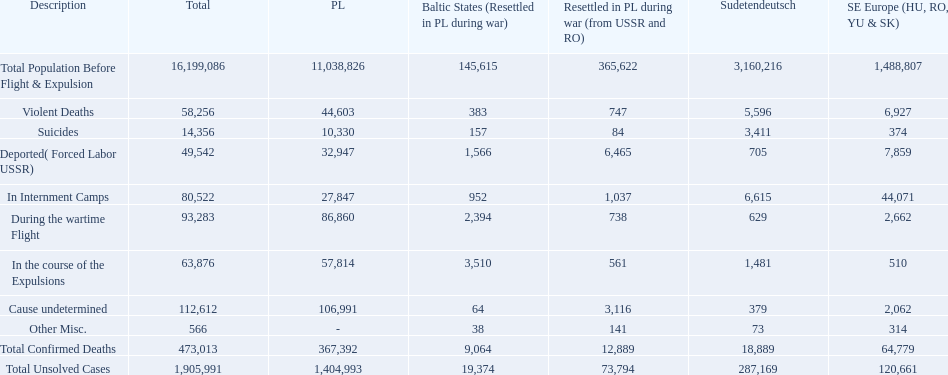What are the numbers of violent deaths across the area? 44,603, 383, 747, 5,596, 6,927. What is the total number of violent deaths of the area? 58,256. Could you parse the entire table? {'header': ['Description', 'Total', 'PL', 'Baltic States (Resettled in PL during war)', 'Resettled in PL during war (from USSR and RO)', 'Sudetendeutsch', 'SE Europe (HU, RO, YU & SK)'], 'rows': [['Total Population Before Flight & Expulsion', '16,199,086', '11,038,826', '145,615', '365,622', '3,160,216', '1,488,807'], ['Violent Deaths', '58,256', '44,603', '383', '747', '5,596', '6,927'], ['Suicides', '14,356', '10,330', '157', '84', '3,411', '374'], ['Deported( Forced Labor USSR)', '49,542', '32,947', '1,566', '6,465', '705', '7,859'], ['In Internment Camps', '80,522', '27,847', '952', '1,037', '6,615', '44,071'], ['During the wartime Flight', '93,283', '86,860', '2,394', '738', '629', '2,662'], ['In the course of the Expulsions', '63,876', '57,814', '3,510', '561', '1,481', '510'], ['Cause undetermined', '112,612', '106,991', '64', '3,116', '379', '2,062'], ['Other Misc.', '566', '-', '38', '141', '73', '314'], ['Total Confirmed Deaths', '473,013', '367,392', '9,064', '12,889', '18,889', '64,779'], ['Total Unsolved Cases', '1,905,991', '1,404,993', '19,374', '73,794', '287,169', '120,661']]} 